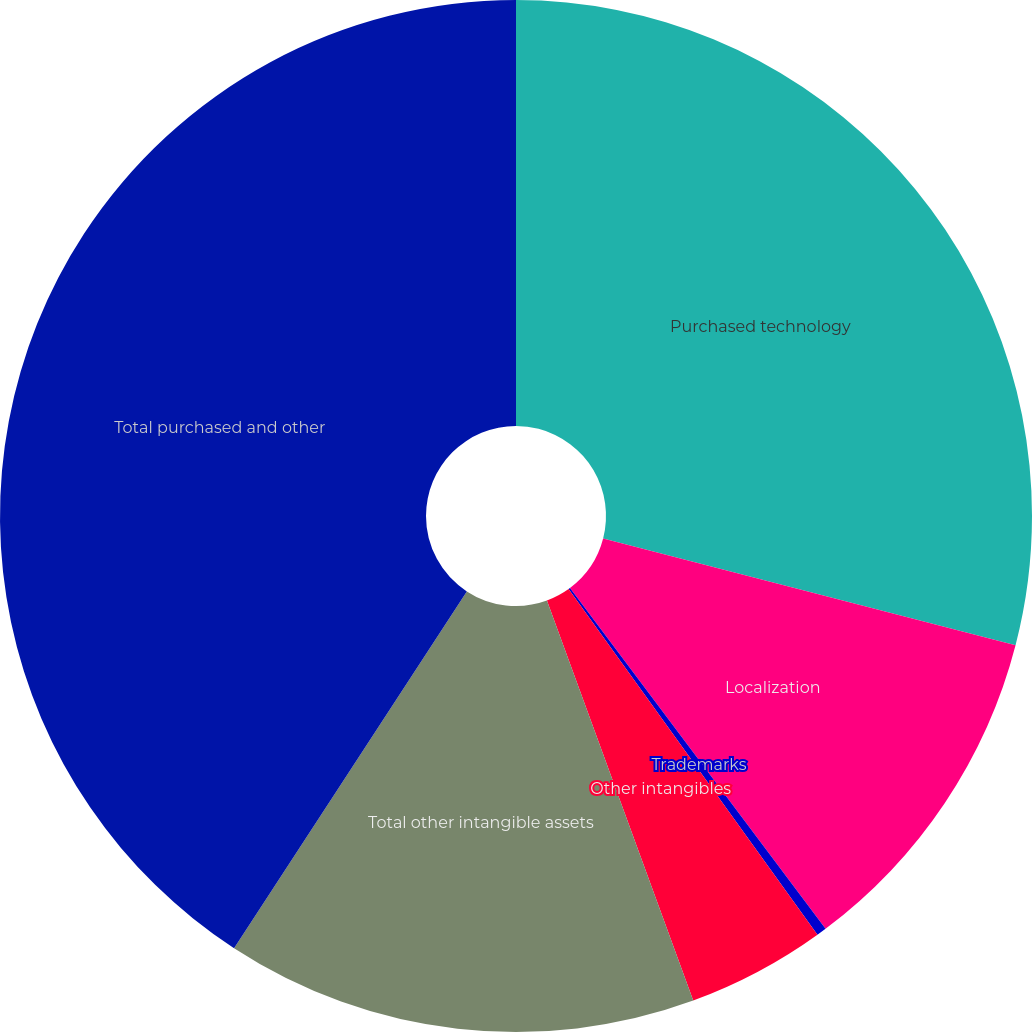<chart> <loc_0><loc_0><loc_500><loc_500><pie_chart><fcel>Purchased technology<fcel>Localization<fcel>Trademarks<fcel>Other intangibles<fcel>Total other intangible assets<fcel>Total purchased and other<nl><fcel>29.03%<fcel>10.73%<fcel>0.31%<fcel>4.35%<fcel>14.78%<fcel>40.8%<nl></chart> 